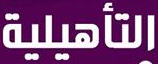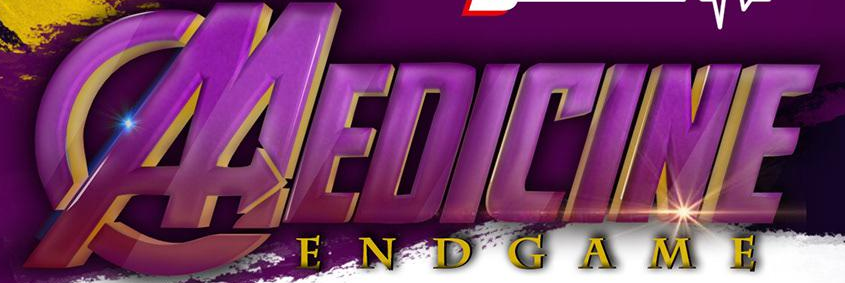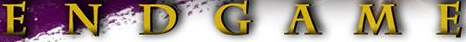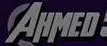Read the text from these images in sequence, separated by a semicolon. ###; MEDICINE; ENDGAME; AHMED 